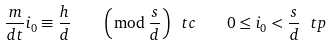Convert formula to latex. <formula><loc_0><loc_0><loc_500><loc_500>\frac { m } { d t } i _ { 0 } \equiv \frac { h } { d } \quad \left ( \bmod \, \frac { s } { d } \right ) \ t c \quad 0 \leq i _ { 0 } < \frac { s } { d } \ t p</formula> 